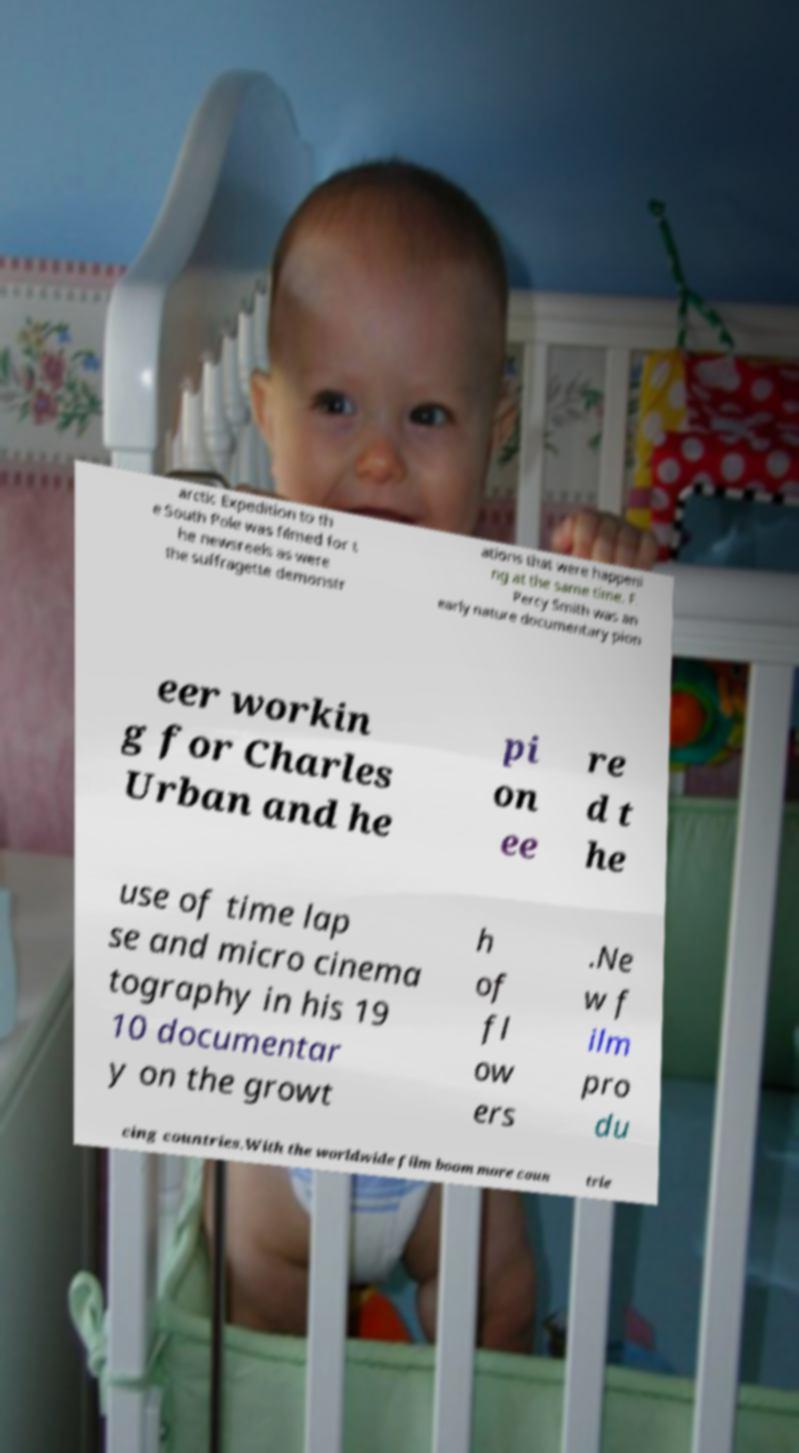Could you assist in decoding the text presented in this image and type it out clearly? arctic Expedition to th e South Pole was filmed for t he newsreels as were the suffragette demonstr ations that were happeni ng at the same time. F. Percy Smith was an early nature documentary pion eer workin g for Charles Urban and he pi on ee re d t he use of time lap se and micro cinema tography in his 19 10 documentar y on the growt h of fl ow ers .Ne w f ilm pro du cing countries.With the worldwide film boom more coun trie 